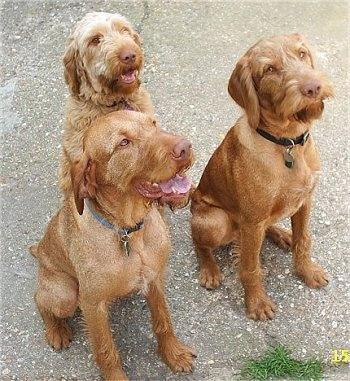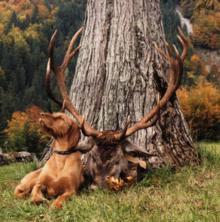The first image is the image on the left, the second image is the image on the right. Considering the images on both sides, is "All of the brown dogs are wearing collars." valid? Answer yes or no. Yes. The first image is the image on the left, the second image is the image on the right. Evaluate the accuracy of this statement regarding the images: "There are only two dogs in the pair of images.". Is it true? Answer yes or no. No. 